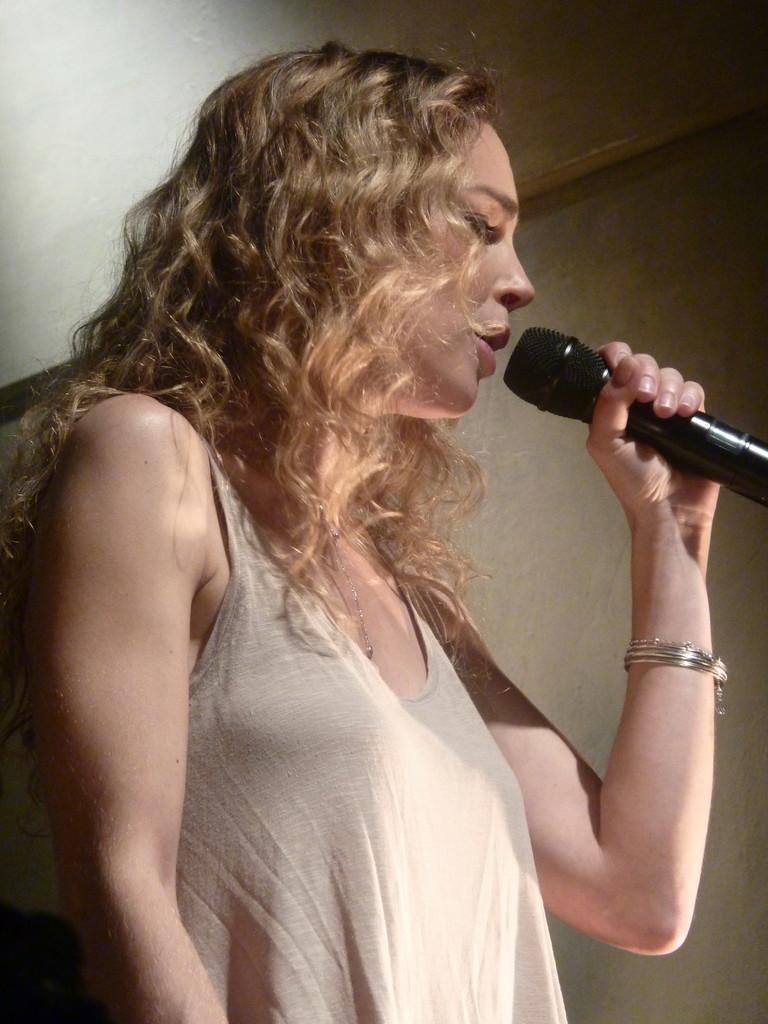How would you summarize this image in a sentence or two? This picture shows a woman Standing and singing with the help of a microphone in her hand 